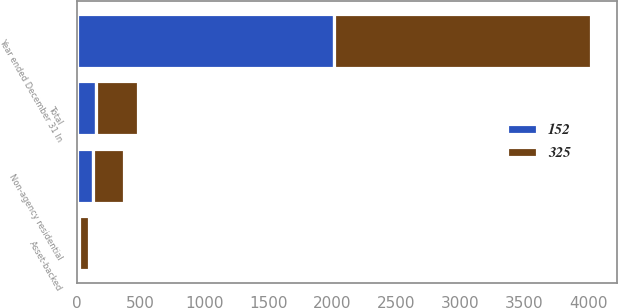Convert chart. <chart><loc_0><loc_0><loc_500><loc_500><stacked_bar_chart><ecel><fcel>Year ended December 31 In<fcel>Non-agency residential<fcel>Asset-backed<fcel>Total<nl><fcel>152<fcel>2011<fcel>130<fcel>21<fcel>152<nl><fcel>325<fcel>2010<fcel>242<fcel>78<fcel>325<nl></chart> 